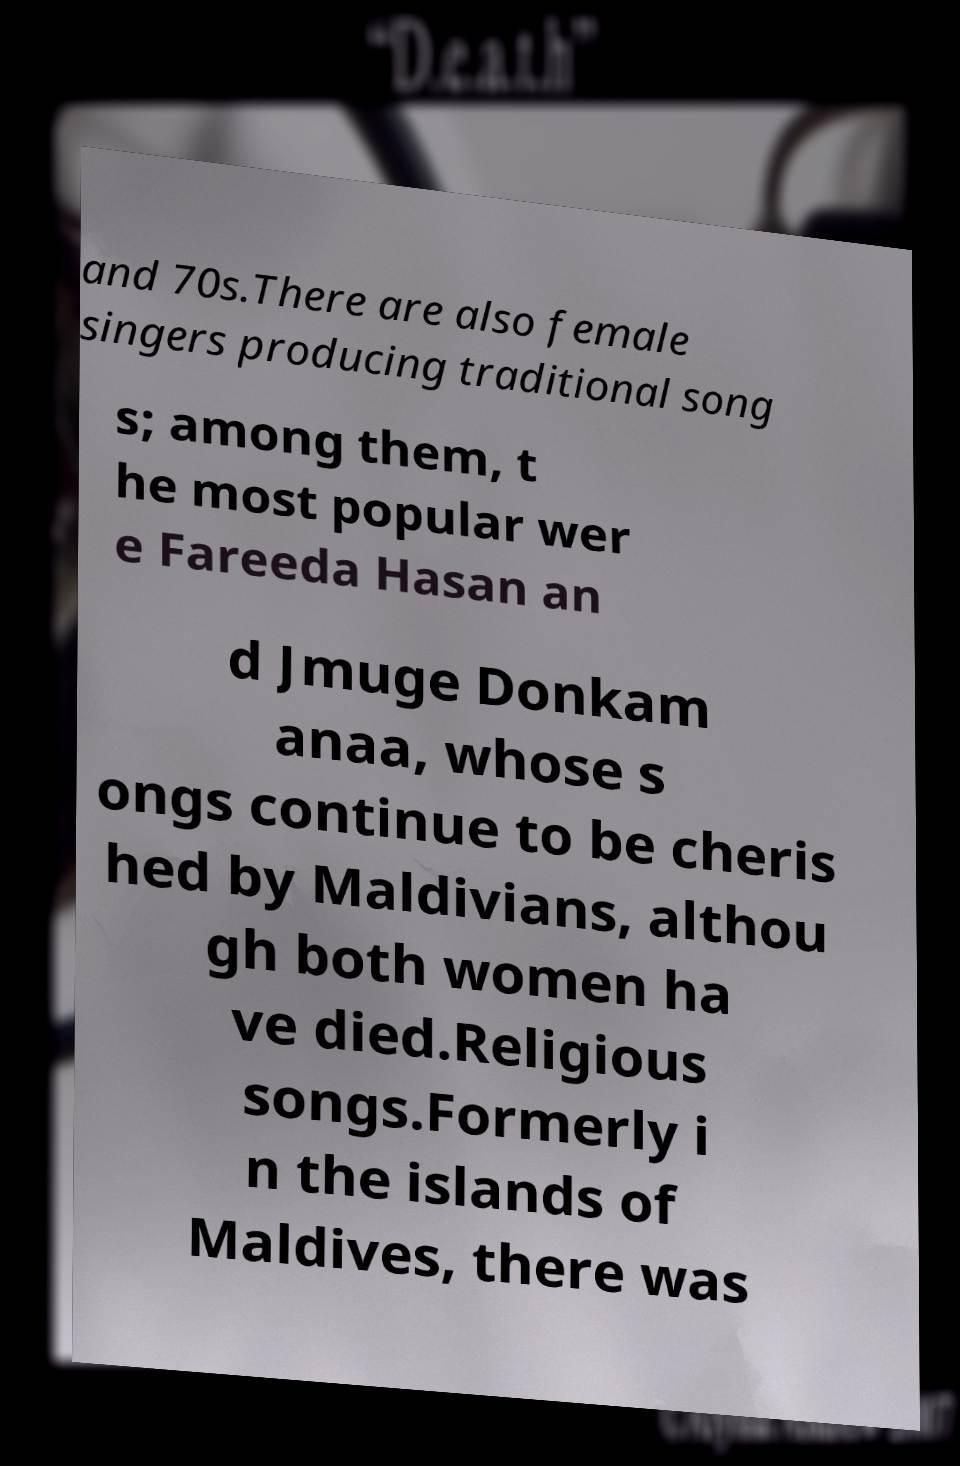What messages or text are displayed in this image? I need them in a readable, typed format. and 70s.There are also female singers producing traditional song s; among them, t he most popular wer e Fareeda Hasan an d Jmuge Donkam anaa, whose s ongs continue to be cheris hed by Maldivians, althou gh both women ha ve died.Religious songs.Formerly i n the islands of Maldives, there was 